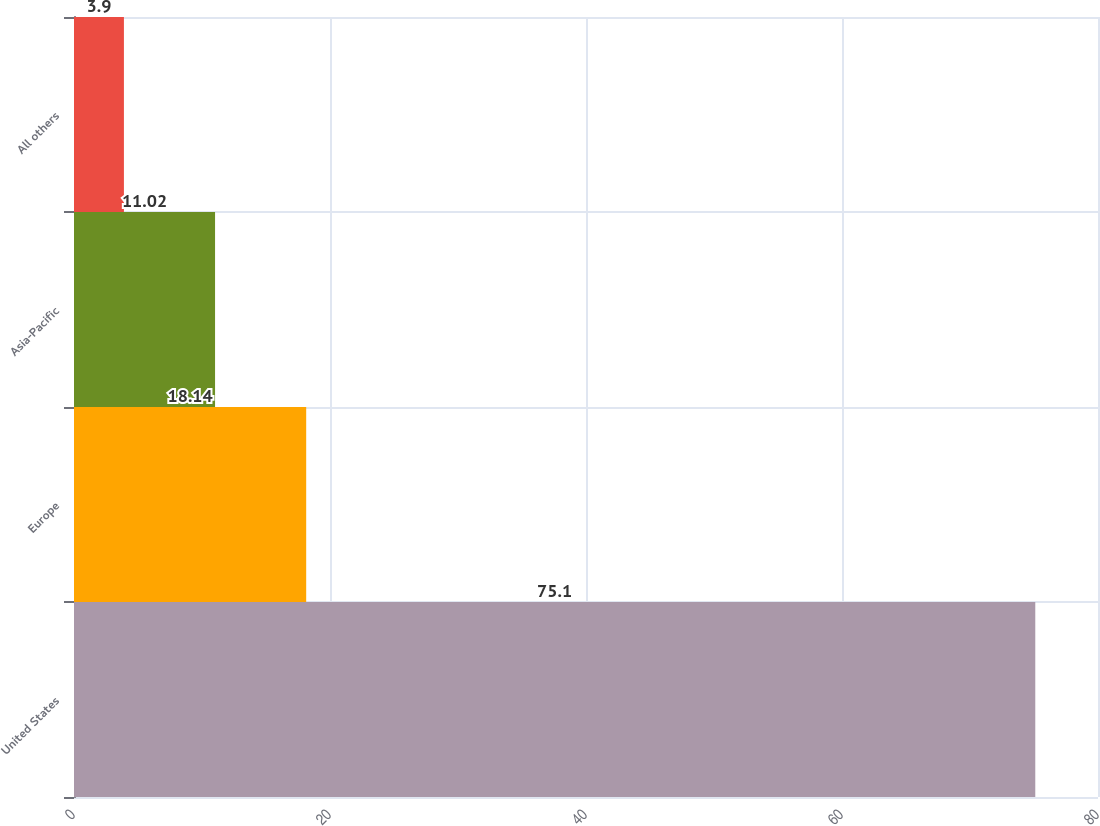Convert chart to OTSL. <chart><loc_0><loc_0><loc_500><loc_500><bar_chart><fcel>United States<fcel>Europe<fcel>Asia-Pacific<fcel>All others<nl><fcel>75.1<fcel>18.14<fcel>11.02<fcel>3.9<nl></chart> 